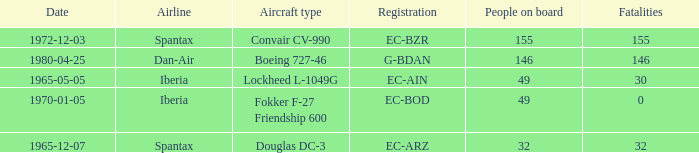How many fatalities shows for the lockheed l-1049g? 30.0. 